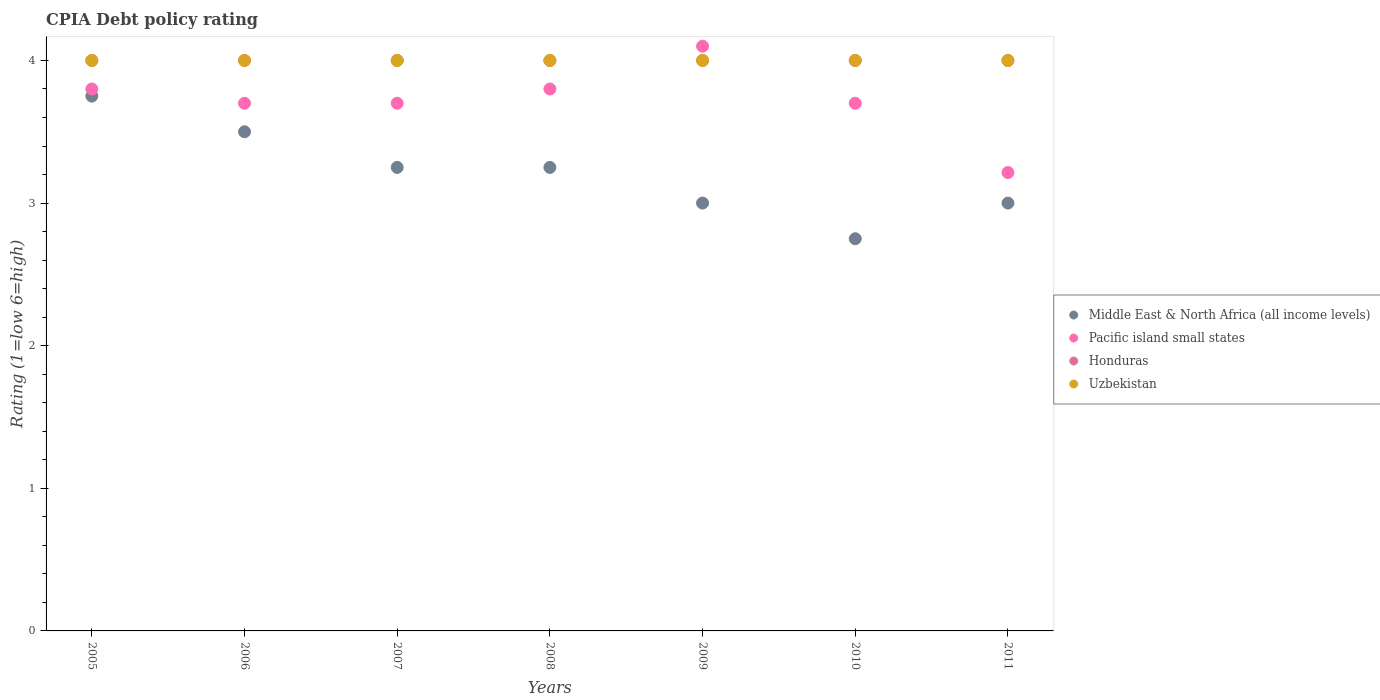What is the CPIA rating in Pacific island small states in 2008?
Your answer should be compact. 3.8. Across all years, what is the maximum CPIA rating in Uzbekistan?
Offer a terse response. 4. In which year was the CPIA rating in Middle East & North Africa (all income levels) maximum?
Make the answer very short. 2005. What is the total CPIA rating in Uzbekistan in the graph?
Ensure brevity in your answer.  28. What is the difference between the CPIA rating in Honduras in 2007 and that in 2010?
Your response must be concise. 0. What is the average CPIA rating in Honduras per year?
Offer a very short reply. 4. In the year 2007, what is the difference between the CPIA rating in Middle East & North Africa (all income levels) and CPIA rating in Honduras?
Make the answer very short. -0.75. In how many years, is the CPIA rating in Uzbekistan greater than 2.2?
Provide a short and direct response. 7. What is the ratio of the CPIA rating in Pacific island small states in 2008 to that in 2011?
Your answer should be compact. 1.18. Is the difference between the CPIA rating in Middle East & North Africa (all income levels) in 2009 and 2011 greater than the difference between the CPIA rating in Honduras in 2009 and 2011?
Your response must be concise. No. What is the difference between the highest and the second highest CPIA rating in Middle East & North Africa (all income levels)?
Give a very brief answer. 0.25. What is the difference between the highest and the lowest CPIA rating in Pacific island small states?
Offer a very short reply. 0.89. Is it the case that in every year, the sum of the CPIA rating in Honduras and CPIA rating in Uzbekistan  is greater than the sum of CPIA rating in Middle East & North Africa (all income levels) and CPIA rating in Pacific island small states?
Your response must be concise. No. Is it the case that in every year, the sum of the CPIA rating in Pacific island small states and CPIA rating in Honduras  is greater than the CPIA rating in Uzbekistan?
Ensure brevity in your answer.  Yes. Does the CPIA rating in Middle East & North Africa (all income levels) monotonically increase over the years?
Keep it short and to the point. No. Is the CPIA rating in Middle East & North Africa (all income levels) strictly greater than the CPIA rating in Uzbekistan over the years?
Provide a short and direct response. No. How many dotlines are there?
Provide a succinct answer. 4. How many years are there in the graph?
Provide a succinct answer. 7. Are the values on the major ticks of Y-axis written in scientific E-notation?
Make the answer very short. No. Does the graph contain grids?
Keep it short and to the point. No. Where does the legend appear in the graph?
Your answer should be very brief. Center right. How are the legend labels stacked?
Give a very brief answer. Vertical. What is the title of the graph?
Provide a succinct answer. CPIA Debt policy rating. Does "Myanmar" appear as one of the legend labels in the graph?
Offer a very short reply. No. What is the label or title of the X-axis?
Your answer should be very brief. Years. What is the label or title of the Y-axis?
Keep it short and to the point. Rating (1=low 6=high). What is the Rating (1=low 6=high) in Middle East & North Africa (all income levels) in 2005?
Your response must be concise. 3.75. What is the Rating (1=low 6=high) in Honduras in 2005?
Provide a short and direct response. 4. What is the Rating (1=low 6=high) of Uzbekistan in 2005?
Offer a very short reply. 4. What is the Rating (1=low 6=high) of Middle East & North Africa (all income levels) in 2007?
Provide a succinct answer. 3.25. What is the Rating (1=low 6=high) in Pacific island small states in 2007?
Ensure brevity in your answer.  3.7. What is the Rating (1=low 6=high) in Pacific island small states in 2008?
Keep it short and to the point. 3.8. What is the Rating (1=low 6=high) of Pacific island small states in 2009?
Ensure brevity in your answer.  4.1. What is the Rating (1=low 6=high) of Middle East & North Africa (all income levels) in 2010?
Offer a very short reply. 2.75. What is the Rating (1=low 6=high) in Pacific island small states in 2010?
Ensure brevity in your answer.  3.7. What is the Rating (1=low 6=high) of Pacific island small states in 2011?
Provide a succinct answer. 3.21. Across all years, what is the maximum Rating (1=low 6=high) in Middle East & North Africa (all income levels)?
Give a very brief answer. 3.75. Across all years, what is the maximum Rating (1=low 6=high) in Pacific island small states?
Provide a short and direct response. 4.1. Across all years, what is the minimum Rating (1=low 6=high) of Middle East & North Africa (all income levels)?
Provide a succinct answer. 2.75. Across all years, what is the minimum Rating (1=low 6=high) of Pacific island small states?
Your answer should be compact. 3.21. What is the total Rating (1=low 6=high) of Middle East & North Africa (all income levels) in the graph?
Offer a terse response. 22.5. What is the total Rating (1=low 6=high) in Pacific island small states in the graph?
Your response must be concise. 26.01. What is the total Rating (1=low 6=high) in Uzbekistan in the graph?
Your answer should be very brief. 28. What is the difference between the Rating (1=low 6=high) in Pacific island small states in 2005 and that in 2007?
Provide a succinct answer. 0.1. What is the difference between the Rating (1=low 6=high) in Uzbekistan in 2005 and that in 2007?
Give a very brief answer. 0. What is the difference between the Rating (1=low 6=high) of Middle East & North Africa (all income levels) in 2005 and that in 2008?
Give a very brief answer. 0.5. What is the difference between the Rating (1=low 6=high) of Pacific island small states in 2005 and that in 2008?
Your answer should be compact. 0. What is the difference between the Rating (1=low 6=high) of Honduras in 2005 and that in 2008?
Offer a terse response. 0. What is the difference between the Rating (1=low 6=high) of Uzbekistan in 2005 and that in 2008?
Make the answer very short. 0. What is the difference between the Rating (1=low 6=high) of Middle East & North Africa (all income levels) in 2005 and that in 2009?
Provide a short and direct response. 0.75. What is the difference between the Rating (1=low 6=high) in Honduras in 2005 and that in 2009?
Your answer should be compact. 0. What is the difference between the Rating (1=low 6=high) in Middle East & North Africa (all income levels) in 2005 and that in 2010?
Your answer should be very brief. 1. What is the difference between the Rating (1=low 6=high) in Pacific island small states in 2005 and that in 2010?
Your response must be concise. 0.1. What is the difference between the Rating (1=low 6=high) in Honduras in 2005 and that in 2010?
Keep it short and to the point. 0. What is the difference between the Rating (1=low 6=high) of Pacific island small states in 2005 and that in 2011?
Give a very brief answer. 0.59. What is the difference between the Rating (1=low 6=high) of Uzbekistan in 2005 and that in 2011?
Your answer should be compact. 0. What is the difference between the Rating (1=low 6=high) of Pacific island small states in 2006 and that in 2008?
Your answer should be very brief. -0.1. What is the difference between the Rating (1=low 6=high) of Honduras in 2006 and that in 2008?
Ensure brevity in your answer.  0. What is the difference between the Rating (1=low 6=high) in Middle East & North Africa (all income levels) in 2006 and that in 2009?
Offer a very short reply. 0.5. What is the difference between the Rating (1=low 6=high) of Honduras in 2006 and that in 2009?
Your answer should be very brief. 0. What is the difference between the Rating (1=low 6=high) of Uzbekistan in 2006 and that in 2009?
Keep it short and to the point. 0. What is the difference between the Rating (1=low 6=high) in Pacific island small states in 2006 and that in 2010?
Give a very brief answer. 0. What is the difference between the Rating (1=low 6=high) in Honduras in 2006 and that in 2010?
Offer a terse response. 0. What is the difference between the Rating (1=low 6=high) of Pacific island small states in 2006 and that in 2011?
Ensure brevity in your answer.  0.49. What is the difference between the Rating (1=low 6=high) of Honduras in 2006 and that in 2011?
Your answer should be very brief. 0. What is the difference between the Rating (1=low 6=high) in Uzbekistan in 2006 and that in 2011?
Your answer should be very brief. 0. What is the difference between the Rating (1=low 6=high) of Middle East & North Africa (all income levels) in 2007 and that in 2008?
Your response must be concise. 0. What is the difference between the Rating (1=low 6=high) in Honduras in 2007 and that in 2008?
Offer a very short reply. 0. What is the difference between the Rating (1=low 6=high) in Uzbekistan in 2007 and that in 2008?
Offer a very short reply. 0. What is the difference between the Rating (1=low 6=high) of Honduras in 2007 and that in 2009?
Your response must be concise. 0. What is the difference between the Rating (1=low 6=high) of Honduras in 2007 and that in 2010?
Make the answer very short. 0. What is the difference between the Rating (1=low 6=high) of Middle East & North Africa (all income levels) in 2007 and that in 2011?
Offer a terse response. 0.25. What is the difference between the Rating (1=low 6=high) in Pacific island small states in 2007 and that in 2011?
Keep it short and to the point. 0.49. What is the difference between the Rating (1=low 6=high) in Honduras in 2007 and that in 2011?
Offer a terse response. 0. What is the difference between the Rating (1=low 6=high) in Uzbekistan in 2007 and that in 2011?
Your answer should be very brief. 0. What is the difference between the Rating (1=low 6=high) of Middle East & North Africa (all income levels) in 2008 and that in 2009?
Your answer should be very brief. 0.25. What is the difference between the Rating (1=low 6=high) in Honduras in 2008 and that in 2009?
Keep it short and to the point. 0. What is the difference between the Rating (1=low 6=high) in Uzbekistan in 2008 and that in 2009?
Offer a very short reply. 0. What is the difference between the Rating (1=low 6=high) in Middle East & North Africa (all income levels) in 2008 and that in 2010?
Keep it short and to the point. 0.5. What is the difference between the Rating (1=low 6=high) in Pacific island small states in 2008 and that in 2010?
Provide a succinct answer. 0.1. What is the difference between the Rating (1=low 6=high) in Pacific island small states in 2008 and that in 2011?
Your response must be concise. 0.59. What is the difference between the Rating (1=low 6=high) of Uzbekistan in 2008 and that in 2011?
Keep it short and to the point. 0. What is the difference between the Rating (1=low 6=high) in Honduras in 2009 and that in 2010?
Keep it short and to the point. 0. What is the difference between the Rating (1=low 6=high) in Middle East & North Africa (all income levels) in 2009 and that in 2011?
Your response must be concise. 0. What is the difference between the Rating (1=low 6=high) of Pacific island small states in 2009 and that in 2011?
Your answer should be compact. 0.89. What is the difference between the Rating (1=low 6=high) in Honduras in 2009 and that in 2011?
Your response must be concise. 0. What is the difference between the Rating (1=low 6=high) of Middle East & North Africa (all income levels) in 2010 and that in 2011?
Ensure brevity in your answer.  -0.25. What is the difference between the Rating (1=low 6=high) of Pacific island small states in 2010 and that in 2011?
Your answer should be compact. 0.49. What is the difference between the Rating (1=low 6=high) of Honduras in 2010 and that in 2011?
Your answer should be compact. 0. What is the difference between the Rating (1=low 6=high) in Uzbekistan in 2010 and that in 2011?
Keep it short and to the point. 0. What is the difference between the Rating (1=low 6=high) of Middle East & North Africa (all income levels) in 2005 and the Rating (1=low 6=high) of Honduras in 2006?
Offer a terse response. -0.25. What is the difference between the Rating (1=low 6=high) of Middle East & North Africa (all income levels) in 2005 and the Rating (1=low 6=high) of Pacific island small states in 2007?
Your answer should be compact. 0.05. What is the difference between the Rating (1=low 6=high) in Middle East & North Africa (all income levels) in 2005 and the Rating (1=low 6=high) in Uzbekistan in 2007?
Offer a terse response. -0.25. What is the difference between the Rating (1=low 6=high) in Middle East & North Africa (all income levels) in 2005 and the Rating (1=low 6=high) in Pacific island small states in 2008?
Provide a succinct answer. -0.05. What is the difference between the Rating (1=low 6=high) of Middle East & North Africa (all income levels) in 2005 and the Rating (1=low 6=high) of Honduras in 2008?
Ensure brevity in your answer.  -0.25. What is the difference between the Rating (1=low 6=high) of Middle East & North Africa (all income levels) in 2005 and the Rating (1=low 6=high) of Uzbekistan in 2008?
Provide a short and direct response. -0.25. What is the difference between the Rating (1=low 6=high) in Pacific island small states in 2005 and the Rating (1=low 6=high) in Uzbekistan in 2008?
Provide a short and direct response. -0.2. What is the difference between the Rating (1=low 6=high) in Middle East & North Africa (all income levels) in 2005 and the Rating (1=low 6=high) in Pacific island small states in 2009?
Provide a short and direct response. -0.35. What is the difference between the Rating (1=low 6=high) in Middle East & North Africa (all income levels) in 2005 and the Rating (1=low 6=high) in Honduras in 2009?
Provide a short and direct response. -0.25. What is the difference between the Rating (1=low 6=high) in Middle East & North Africa (all income levels) in 2005 and the Rating (1=low 6=high) in Uzbekistan in 2009?
Keep it short and to the point. -0.25. What is the difference between the Rating (1=low 6=high) of Pacific island small states in 2005 and the Rating (1=low 6=high) of Honduras in 2009?
Give a very brief answer. -0.2. What is the difference between the Rating (1=low 6=high) in Middle East & North Africa (all income levels) in 2005 and the Rating (1=low 6=high) in Honduras in 2010?
Your answer should be compact. -0.25. What is the difference between the Rating (1=low 6=high) in Middle East & North Africa (all income levels) in 2005 and the Rating (1=low 6=high) in Uzbekistan in 2010?
Give a very brief answer. -0.25. What is the difference between the Rating (1=low 6=high) of Pacific island small states in 2005 and the Rating (1=low 6=high) of Uzbekistan in 2010?
Provide a short and direct response. -0.2. What is the difference between the Rating (1=low 6=high) of Honduras in 2005 and the Rating (1=low 6=high) of Uzbekistan in 2010?
Provide a succinct answer. 0. What is the difference between the Rating (1=low 6=high) in Middle East & North Africa (all income levels) in 2005 and the Rating (1=low 6=high) in Pacific island small states in 2011?
Make the answer very short. 0.54. What is the difference between the Rating (1=low 6=high) of Middle East & North Africa (all income levels) in 2005 and the Rating (1=low 6=high) of Honduras in 2011?
Offer a very short reply. -0.25. What is the difference between the Rating (1=low 6=high) in Middle East & North Africa (all income levels) in 2005 and the Rating (1=low 6=high) in Uzbekistan in 2011?
Make the answer very short. -0.25. What is the difference between the Rating (1=low 6=high) of Middle East & North Africa (all income levels) in 2006 and the Rating (1=low 6=high) of Pacific island small states in 2007?
Your response must be concise. -0.2. What is the difference between the Rating (1=low 6=high) in Middle East & North Africa (all income levels) in 2006 and the Rating (1=low 6=high) in Uzbekistan in 2007?
Provide a succinct answer. -0.5. What is the difference between the Rating (1=low 6=high) of Honduras in 2006 and the Rating (1=low 6=high) of Uzbekistan in 2007?
Provide a succinct answer. 0. What is the difference between the Rating (1=low 6=high) of Middle East & North Africa (all income levels) in 2006 and the Rating (1=low 6=high) of Uzbekistan in 2008?
Your answer should be very brief. -0.5. What is the difference between the Rating (1=low 6=high) in Pacific island small states in 2006 and the Rating (1=low 6=high) in Honduras in 2008?
Make the answer very short. -0.3. What is the difference between the Rating (1=low 6=high) in Pacific island small states in 2006 and the Rating (1=low 6=high) in Uzbekistan in 2008?
Your answer should be very brief. -0.3. What is the difference between the Rating (1=low 6=high) of Middle East & North Africa (all income levels) in 2006 and the Rating (1=low 6=high) of Honduras in 2009?
Give a very brief answer. -0.5. What is the difference between the Rating (1=low 6=high) in Honduras in 2006 and the Rating (1=low 6=high) in Uzbekistan in 2009?
Offer a terse response. 0. What is the difference between the Rating (1=low 6=high) of Middle East & North Africa (all income levels) in 2006 and the Rating (1=low 6=high) of Honduras in 2010?
Provide a short and direct response. -0.5. What is the difference between the Rating (1=low 6=high) of Middle East & North Africa (all income levels) in 2006 and the Rating (1=low 6=high) of Uzbekistan in 2010?
Your answer should be compact. -0.5. What is the difference between the Rating (1=low 6=high) of Pacific island small states in 2006 and the Rating (1=low 6=high) of Honduras in 2010?
Offer a terse response. -0.3. What is the difference between the Rating (1=low 6=high) of Honduras in 2006 and the Rating (1=low 6=high) of Uzbekistan in 2010?
Your response must be concise. 0. What is the difference between the Rating (1=low 6=high) of Middle East & North Africa (all income levels) in 2006 and the Rating (1=low 6=high) of Pacific island small states in 2011?
Provide a succinct answer. 0.29. What is the difference between the Rating (1=low 6=high) of Pacific island small states in 2006 and the Rating (1=low 6=high) of Honduras in 2011?
Your answer should be compact. -0.3. What is the difference between the Rating (1=low 6=high) in Pacific island small states in 2006 and the Rating (1=low 6=high) in Uzbekistan in 2011?
Offer a very short reply. -0.3. What is the difference between the Rating (1=low 6=high) in Middle East & North Africa (all income levels) in 2007 and the Rating (1=low 6=high) in Pacific island small states in 2008?
Your answer should be compact. -0.55. What is the difference between the Rating (1=low 6=high) of Middle East & North Africa (all income levels) in 2007 and the Rating (1=low 6=high) of Honduras in 2008?
Provide a short and direct response. -0.75. What is the difference between the Rating (1=low 6=high) of Middle East & North Africa (all income levels) in 2007 and the Rating (1=low 6=high) of Uzbekistan in 2008?
Ensure brevity in your answer.  -0.75. What is the difference between the Rating (1=low 6=high) of Pacific island small states in 2007 and the Rating (1=low 6=high) of Honduras in 2008?
Provide a short and direct response. -0.3. What is the difference between the Rating (1=low 6=high) of Pacific island small states in 2007 and the Rating (1=low 6=high) of Uzbekistan in 2008?
Your answer should be compact. -0.3. What is the difference between the Rating (1=low 6=high) of Middle East & North Africa (all income levels) in 2007 and the Rating (1=low 6=high) of Pacific island small states in 2009?
Your answer should be very brief. -0.85. What is the difference between the Rating (1=low 6=high) in Middle East & North Africa (all income levels) in 2007 and the Rating (1=low 6=high) in Honduras in 2009?
Offer a terse response. -0.75. What is the difference between the Rating (1=low 6=high) of Middle East & North Africa (all income levels) in 2007 and the Rating (1=low 6=high) of Uzbekistan in 2009?
Offer a terse response. -0.75. What is the difference between the Rating (1=low 6=high) of Pacific island small states in 2007 and the Rating (1=low 6=high) of Honduras in 2009?
Ensure brevity in your answer.  -0.3. What is the difference between the Rating (1=low 6=high) of Pacific island small states in 2007 and the Rating (1=low 6=high) of Uzbekistan in 2009?
Offer a terse response. -0.3. What is the difference between the Rating (1=low 6=high) of Middle East & North Africa (all income levels) in 2007 and the Rating (1=low 6=high) of Pacific island small states in 2010?
Offer a terse response. -0.45. What is the difference between the Rating (1=low 6=high) in Middle East & North Africa (all income levels) in 2007 and the Rating (1=low 6=high) in Honduras in 2010?
Make the answer very short. -0.75. What is the difference between the Rating (1=low 6=high) of Middle East & North Africa (all income levels) in 2007 and the Rating (1=low 6=high) of Uzbekistan in 2010?
Your answer should be compact. -0.75. What is the difference between the Rating (1=low 6=high) of Pacific island small states in 2007 and the Rating (1=low 6=high) of Honduras in 2010?
Keep it short and to the point. -0.3. What is the difference between the Rating (1=low 6=high) in Honduras in 2007 and the Rating (1=low 6=high) in Uzbekistan in 2010?
Provide a succinct answer. 0. What is the difference between the Rating (1=low 6=high) in Middle East & North Africa (all income levels) in 2007 and the Rating (1=low 6=high) in Pacific island small states in 2011?
Provide a succinct answer. 0.04. What is the difference between the Rating (1=low 6=high) of Middle East & North Africa (all income levels) in 2007 and the Rating (1=low 6=high) of Honduras in 2011?
Make the answer very short. -0.75. What is the difference between the Rating (1=low 6=high) of Middle East & North Africa (all income levels) in 2007 and the Rating (1=low 6=high) of Uzbekistan in 2011?
Your answer should be very brief. -0.75. What is the difference between the Rating (1=low 6=high) of Honduras in 2007 and the Rating (1=low 6=high) of Uzbekistan in 2011?
Your answer should be very brief. 0. What is the difference between the Rating (1=low 6=high) in Middle East & North Africa (all income levels) in 2008 and the Rating (1=low 6=high) in Pacific island small states in 2009?
Provide a short and direct response. -0.85. What is the difference between the Rating (1=low 6=high) of Middle East & North Africa (all income levels) in 2008 and the Rating (1=low 6=high) of Honduras in 2009?
Keep it short and to the point. -0.75. What is the difference between the Rating (1=low 6=high) of Middle East & North Africa (all income levels) in 2008 and the Rating (1=low 6=high) of Uzbekistan in 2009?
Provide a short and direct response. -0.75. What is the difference between the Rating (1=low 6=high) of Pacific island small states in 2008 and the Rating (1=low 6=high) of Honduras in 2009?
Provide a short and direct response. -0.2. What is the difference between the Rating (1=low 6=high) in Pacific island small states in 2008 and the Rating (1=low 6=high) in Uzbekistan in 2009?
Provide a succinct answer. -0.2. What is the difference between the Rating (1=low 6=high) of Middle East & North Africa (all income levels) in 2008 and the Rating (1=low 6=high) of Pacific island small states in 2010?
Your answer should be compact. -0.45. What is the difference between the Rating (1=low 6=high) of Middle East & North Africa (all income levels) in 2008 and the Rating (1=low 6=high) of Honduras in 2010?
Offer a terse response. -0.75. What is the difference between the Rating (1=low 6=high) of Middle East & North Africa (all income levels) in 2008 and the Rating (1=low 6=high) of Uzbekistan in 2010?
Your answer should be compact. -0.75. What is the difference between the Rating (1=low 6=high) of Pacific island small states in 2008 and the Rating (1=low 6=high) of Uzbekistan in 2010?
Your response must be concise. -0.2. What is the difference between the Rating (1=low 6=high) in Honduras in 2008 and the Rating (1=low 6=high) in Uzbekistan in 2010?
Keep it short and to the point. 0. What is the difference between the Rating (1=low 6=high) in Middle East & North Africa (all income levels) in 2008 and the Rating (1=low 6=high) in Pacific island small states in 2011?
Offer a terse response. 0.04. What is the difference between the Rating (1=low 6=high) in Middle East & North Africa (all income levels) in 2008 and the Rating (1=low 6=high) in Honduras in 2011?
Make the answer very short. -0.75. What is the difference between the Rating (1=low 6=high) in Middle East & North Africa (all income levels) in 2008 and the Rating (1=low 6=high) in Uzbekistan in 2011?
Make the answer very short. -0.75. What is the difference between the Rating (1=low 6=high) of Pacific island small states in 2008 and the Rating (1=low 6=high) of Uzbekistan in 2011?
Your response must be concise. -0.2. What is the difference between the Rating (1=low 6=high) of Middle East & North Africa (all income levels) in 2009 and the Rating (1=low 6=high) of Uzbekistan in 2010?
Provide a short and direct response. -1. What is the difference between the Rating (1=low 6=high) of Honduras in 2009 and the Rating (1=low 6=high) of Uzbekistan in 2010?
Give a very brief answer. 0. What is the difference between the Rating (1=low 6=high) of Middle East & North Africa (all income levels) in 2009 and the Rating (1=low 6=high) of Pacific island small states in 2011?
Give a very brief answer. -0.21. What is the difference between the Rating (1=low 6=high) of Middle East & North Africa (all income levels) in 2009 and the Rating (1=low 6=high) of Honduras in 2011?
Your answer should be very brief. -1. What is the difference between the Rating (1=low 6=high) of Middle East & North Africa (all income levels) in 2009 and the Rating (1=low 6=high) of Uzbekistan in 2011?
Make the answer very short. -1. What is the difference between the Rating (1=low 6=high) of Pacific island small states in 2009 and the Rating (1=low 6=high) of Uzbekistan in 2011?
Provide a short and direct response. 0.1. What is the difference between the Rating (1=low 6=high) of Honduras in 2009 and the Rating (1=low 6=high) of Uzbekistan in 2011?
Your answer should be compact. 0. What is the difference between the Rating (1=low 6=high) of Middle East & North Africa (all income levels) in 2010 and the Rating (1=low 6=high) of Pacific island small states in 2011?
Give a very brief answer. -0.46. What is the difference between the Rating (1=low 6=high) in Middle East & North Africa (all income levels) in 2010 and the Rating (1=low 6=high) in Honduras in 2011?
Offer a very short reply. -1.25. What is the difference between the Rating (1=low 6=high) in Middle East & North Africa (all income levels) in 2010 and the Rating (1=low 6=high) in Uzbekistan in 2011?
Provide a short and direct response. -1.25. What is the difference between the Rating (1=low 6=high) of Pacific island small states in 2010 and the Rating (1=low 6=high) of Uzbekistan in 2011?
Provide a short and direct response. -0.3. What is the average Rating (1=low 6=high) in Middle East & North Africa (all income levels) per year?
Your response must be concise. 3.21. What is the average Rating (1=low 6=high) of Pacific island small states per year?
Offer a very short reply. 3.72. In the year 2005, what is the difference between the Rating (1=low 6=high) of Middle East & North Africa (all income levels) and Rating (1=low 6=high) of Pacific island small states?
Ensure brevity in your answer.  -0.05. In the year 2005, what is the difference between the Rating (1=low 6=high) of Honduras and Rating (1=low 6=high) of Uzbekistan?
Offer a terse response. 0. In the year 2006, what is the difference between the Rating (1=low 6=high) in Middle East & North Africa (all income levels) and Rating (1=low 6=high) in Honduras?
Your response must be concise. -0.5. In the year 2006, what is the difference between the Rating (1=low 6=high) in Middle East & North Africa (all income levels) and Rating (1=low 6=high) in Uzbekistan?
Your answer should be compact. -0.5. In the year 2006, what is the difference between the Rating (1=low 6=high) in Honduras and Rating (1=low 6=high) in Uzbekistan?
Offer a very short reply. 0. In the year 2007, what is the difference between the Rating (1=low 6=high) in Middle East & North Africa (all income levels) and Rating (1=low 6=high) in Pacific island small states?
Offer a terse response. -0.45. In the year 2007, what is the difference between the Rating (1=low 6=high) in Middle East & North Africa (all income levels) and Rating (1=low 6=high) in Honduras?
Provide a short and direct response. -0.75. In the year 2007, what is the difference between the Rating (1=low 6=high) of Middle East & North Africa (all income levels) and Rating (1=low 6=high) of Uzbekistan?
Ensure brevity in your answer.  -0.75. In the year 2007, what is the difference between the Rating (1=low 6=high) in Pacific island small states and Rating (1=low 6=high) in Honduras?
Your response must be concise. -0.3. In the year 2008, what is the difference between the Rating (1=low 6=high) in Middle East & North Africa (all income levels) and Rating (1=low 6=high) in Pacific island small states?
Make the answer very short. -0.55. In the year 2008, what is the difference between the Rating (1=low 6=high) in Middle East & North Africa (all income levels) and Rating (1=low 6=high) in Honduras?
Your response must be concise. -0.75. In the year 2008, what is the difference between the Rating (1=low 6=high) in Middle East & North Africa (all income levels) and Rating (1=low 6=high) in Uzbekistan?
Your response must be concise. -0.75. In the year 2008, what is the difference between the Rating (1=low 6=high) of Pacific island small states and Rating (1=low 6=high) of Honduras?
Ensure brevity in your answer.  -0.2. In the year 2008, what is the difference between the Rating (1=low 6=high) in Honduras and Rating (1=low 6=high) in Uzbekistan?
Your answer should be very brief. 0. In the year 2009, what is the difference between the Rating (1=low 6=high) in Middle East & North Africa (all income levels) and Rating (1=low 6=high) in Pacific island small states?
Your answer should be compact. -1.1. In the year 2009, what is the difference between the Rating (1=low 6=high) in Middle East & North Africa (all income levels) and Rating (1=low 6=high) in Honduras?
Make the answer very short. -1. In the year 2009, what is the difference between the Rating (1=low 6=high) in Middle East & North Africa (all income levels) and Rating (1=low 6=high) in Uzbekistan?
Offer a terse response. -1. In the year 2009, what is the difference between the Rating (1=low 6=high) in Pacific island small states and Rating (1=low 6=high) in Uzbekistan?
Your answer should be compact. 0.1. In the year 2009, what is the difference between the Rating (1=low 6=high) of Honduras and Rating (1=low 6=high) of Uzbekistan?
Offer a very short reply. 0. In the year 2010, what is the difference between the Rating (1=low 6=high) in Middle East & North Africa (all income levels) and Rating (1=low 6=high) in Pacific island small states?
Offer a terse response. -0.95. In the year 2010, what is the difference between the Rating (1=low 6=high) of Middle East & North Africa (all income levels) and Rating (1=low 6=high) of Honduras?
Provide a short and direct response. -1.25. In the year 2010, what is the difference between the Rating (1=low 6=high) in Middle East & North Africa (all income levels) and Rating (1=low 6=high) in Uzbekistan?
Provide a short and direct response. -1.25. In the year 2010, what is the difference between the Rating (1=low 6=high) in Pacific island small states and Rating (1=low 6=high) in Honduras?
Offer a very short reply. -0.3. In the year 2010, what is the difference between the Rating (1=low 6=high) of Pacific island small states and Rating (1=low 6=high) of Uzbekistan?
Keep it short and to the point. -0.3. In the year 2010, what is the difference between the Rating (1=low 6=high) in Honduras and Rating (1=low 6=high) in Uzbekistan?
Offer a terse response. 0. In the year 2011, what is the difference between the Rating (1=low 6=high) in Middle East & North Africa (all income levels) and Rating (1=low 6=high) in Pacific island small states?
Keep it short and to the point. -0.21. In the year 2011, what is the difference between the Rating (1=low 6=high) in Middle East & North Africa (all income levels) and Rating (1=low 6=high) in Uzbekistan?
Offer a very short reply. -1. In the year 2011, what is the difference between the Rating (1=low 6=high) of Pacific island small states and Rating (1=low 6=high) of Honduras?
Your response must be concise. -0.79. In the year 2011, what is the difference between the Rating (1=low 6=high) of Pacific island small states and Rating (1=low 6=high) of Uzbekistan?
Offer a terse response. -0.79. In the year 2011, what is the difference between the Rating (1=low 6=high) of Honduras and Rating (1=low 6=high) of Uzbekistan?
Offer a very short reply. 0. What is the ratio of the Rating (1=low 6=high) of Middle East & North Africa (all income levels) in 2005 to that in 2006?
Keep it short and to the point. 1.07. What is the ratio of the Rating (1=low 6=high) in Uzbekistan in 2005 to that in 2006?
Make the answer very short. 1. What is the ratio of the Rating (1=low 6=high) of Middle East & North Africa (all income levels) in 2005 to that in 2007?
Give a very brief answer. 1.15. What is the ratio of the Rating (1=low 6=high) of Pacific island small states in 2005 to that in 2007?
Keep it short and to the point. 1.03. What is the ratio of the Rating (1=low 6=high) of Uzbekistan in 2005 to that in 2007?
Provide a succinct answer. 1. What is the ratio of the Rating (1=low 6=high) in Middle East & North Africa (all income levels) in 2005 to that in 2008?
Your answer should be compact. 1.15. What is the ratio of the Rating (1=low 6=high) of Honduras in 2005 to that in 2008?
Provide a short and direct response. 1. What is the ratio of the Rating (1=low 6=high) of Uzbekistan in 2005 to that in 2008?
Give a very brief answer. 1. What is the ratio of the Rating (1=low 6=high) in Middle East & North Africa (all income levels) in 2005 to that in 2009?
Keep it short and to the point. 1.25. What is the ratio of the Rating (1=low 6=high) in Pacific island small states in 2005 to that in 2009?
Provide a short and direct response. 0.93. What is the ratio of the Rating (1=low 6=high) of Honduras in 2005 to that in 2009?
Your answer should be very brief. 1. What is the ratio of the Rating (1=low 6=high) in Middle East & North Africa (all income levels) in 2005 to that in 2010?
Give a very brief answer. 1.36. What is the ratio of the Rating (1=low 6=high) of Honduras in 2005 to that in 2010?
Ensure brevity in your answer.  1. What is the ratio of the Rating (1=low 6=high) of Uzbekistan in 2005 to that in 2010?
Keep it short and to the point. 1. What is the ratio of the Rating (1=low 6=high) of Middle East & North Africa (all income levels) in 2005 to that in 2011?
Provide a succinct answer. 1.25. What is the ratio of the Rating (1=low 6=high) in Pacific island small states in 2005 to that in 2011?
Offer a very short reply. 1.18. What is the ratio of the Rating (1=low 6=high) of Middle East & North Africa (all income levels) in 2006 to that in 2007?
Offer a very short reply. 1.08. What is the ratio of the Rating (1=low 6=high) in Pacific island small states in 2006 to that in 2007?
Make the answer very short. 1. What is the ratio of the Rating (1=low 6=high) of Middle East & North Africa (all income levels) in 2006 to that in 2008?
Your answer should be compact. 1.08. What is the ratio of the Rating (1=low 6=high) of Pacific island small states in 2006 to that in 2008?
Keep it short and to the point. 0.97. What is the ratio of the Rating (1=low 6=high) in Uzbekistan in 2006 to that in 2008?
Offer a terse response. 1. What is the ratio of the Rating (1=low 6=high) of Pacific island small states in 2006 to that in 2009?
Your answer should be compact. 0.9. What is the ratio of the Rating (1=low 6=high) of Honduras in 2006 to that in 2009?
Keep it short and to the point. 1. What is the ratio of the Rating (1=low 6=high) of Uzbekistan in 2006 to that in 2009?
Ensure brevity in your answer.  1. What is the ratio of the Rating (1=low 6=high) of Middle East & North Africa (all income levels) in 2006 to that in 2010?
Provide a succinct answer. 1.27. What is the ratio of the Rating (1=low 6=high) of Middle East & North Africa (all income levels) in 2006 to that in 2011?
Ensure brevity in your answer.  1.17. What is the ratio of the Rating (1=low 6=high) in Pacific island small states in 2006 to that in 2011?
Ensure brevity in your answer.  1.15. What is the ratio of the Rating (1=low 6=high) in Honduras in 2006 to that in 2011?
Your answer should be compact. 1. What is the ratio of the Rating (1=low 6=high) in Middle East & North Africa (all income levels) in 2007 to that in 2008?
Provide a succinct answer. 1. What is the ratio of the Rating (1=low 6=high) of Pacific island small states in 2007 to that in 2008?
Ensure brevity in your answer.  0.97. What is the ratio of the Rating (1=low 6=high) of Honduras in 2007 to that in 2008?
Provide a succinct answer. 1. What is the ratio of the Rating (1=low 6=high) of Middle East & North Africa (all income levels) in 2007 to that in 2009?
Offer a terse response. 1.08. What is the ratio of the Rating (1=low 6=high) of Pacific island small states in 2007 to that in 2009?
Give a very brief answer. 0.9. What is the ratio of the Rating (1=low 6=high) in Honduras in 2007 to that in 2009?
Your answer should be very brief. 1. What is the ratio of the Rating (1=low 6=high) of Middle East & North Africa (all income levels) in 2007 to that in 2010?
Offer a very short reply. 1.18. What is the ratio of the Rating (1=low 6=high) of Pacific island small states in 2007 to that in 2010?
Offer a very short reply. 1. What is the ratio of the Rating (1=low 6=high) of Pacific island small states in 2007 to that in 2011?
Provide a short and direct response. 1.15. What is the ratio of the Rating (1=low 6=high) in Honduras in 2007 to that in 2011?
Provide a succinct answer. 1. What is the ratio of the Rating (1=low 6=high) of Pacific island small states in 2008 to that in 2009?
Your response must be concise. 0.93. What is the ratio of the Rating (1=low 6=high) of Honduras in 2008 to that in 2009?
Your answer should be compact. 1. What is the ratio of the Rating (1=low 6=high) of Middle East & North Africa (all income levels) in 2008 to that in 2010?
Give a very brief answer. 1.18. What is the ratio of the Rating (1=low 6=high) in Pacific island small states in 2008 to that in 2011?
Your answer should be very brief. 1.18. What is the ratio of the Rating (1=low 6=high) of Honduras in 2008 to that in 2011?
Give a very brief answer. 1. What is the ratio of the Rating (1=low 6=high) of Uzbekistan in 2008 to that in 2011?
Your answer should be very brief. 1. What is the ratio of the Rating (1=low 6=high) of Pacific island small states in 2009 to that in 2010?
Your response must be concise. 1.11. What is the ratio of the Rating (1=low 6=high) in Honduras in 2009 to that in 2010?
Your response must be concise. 1. What is the ratio of the Rating (1=low 6=high) of Pacific island small states in 2009 to that in 2011?
Your answer should be very brief. 1.28. What is the ratio of the Rating (1=low 6=high) of Honduras in 2009 to that in 2011?
Provide a succinct answer. 1. What is the ratio of the Rating (1=low 6=high) of Middle East & North Africa (all income levels) in 2010 to that in 2011?
Make the answer very short. 0.92. What is the ratio of the Rating (1=low 6=high) in Pacific island small states in 2010 to that in 2011?
Make the answer very short. 1.15. What is the difference between the highest and the second highest Rating (1=low 6=high) of Pacific island small states?
Make the answer very short. 0.3. What is the difference between the highest and the lowest Rating (1=low 6=high) in Middle East & North Africa (all income levels)?
Your response must be concise. 1. What is the difference between the highest and the lowest Rating (1=low 6=high) in Pacific island small states?
Your response must be concise. 0.89. What is the difference between the highest and the lowest Rating (1=low 6=high) in Uzbekistan?
Your response must be concise. 0. 